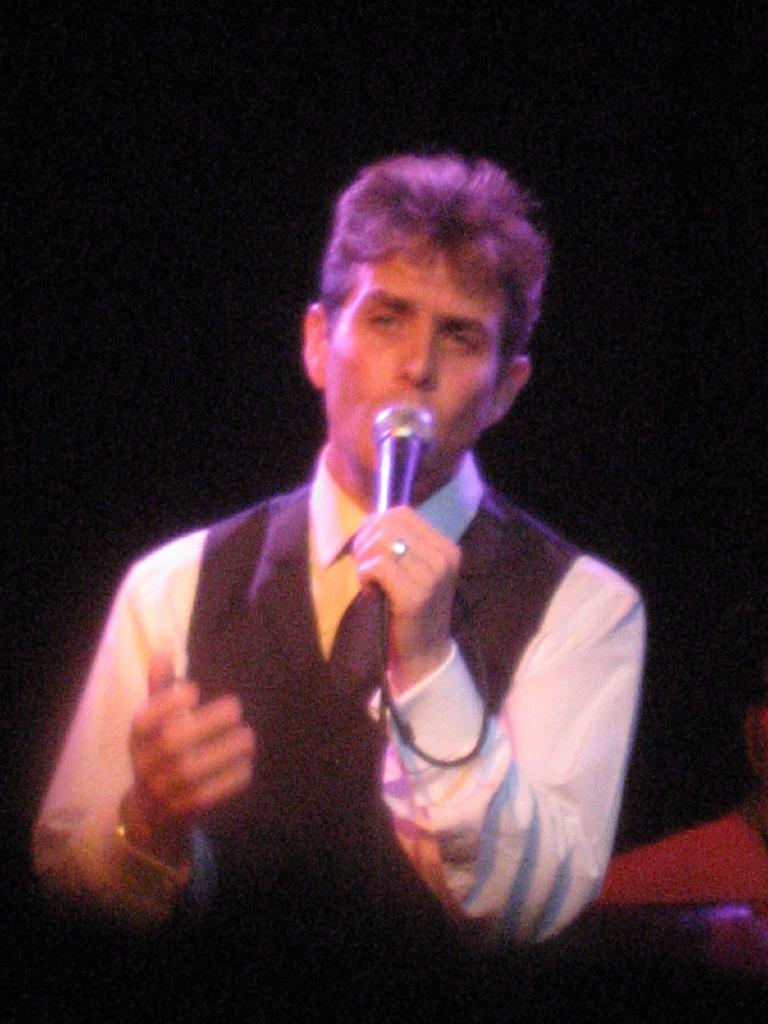Who is the main subject in the image? There is a man in the image. What is the man wearing? The man is wearing a vest. What object is the man holding? The man is holding a microphone. What can be observed about the background of the image? The background of the image is dark. What type of hole can be seen in the man's vest in the image? There is no hole visible in the man's vest in the image. What kind of wood is the man standing on in the image? There is no wood visible in the image, and the man is not standing on any surface. 